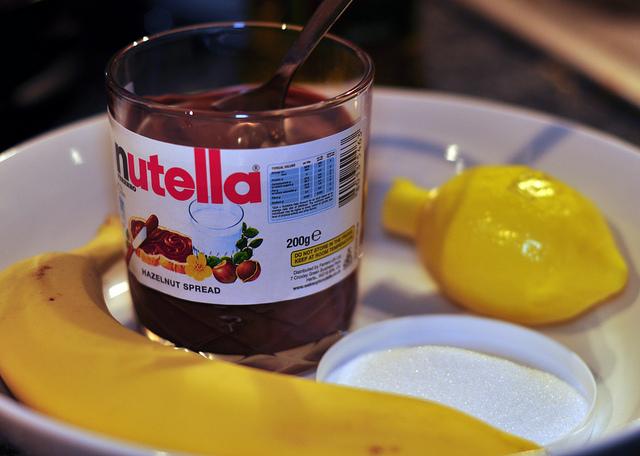Is nutella the same as peanut butter?
Give a very brief answer. No. What fruit is pictured next to the bottle?
Concise answer only. Banana. What kind of spread is nutella?
Give a very brief answer. Hazelnut. Is this food homemade?
Concise answer only. No. Do adults eat nutella?
Give a very brief answer. Yes. 